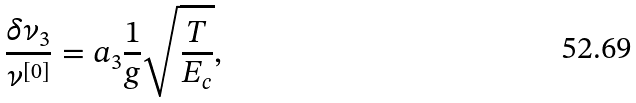Convert formula to latex. <formula><loc_0><loc_0><loc_500><loc_500>\frac { \delta \nu _ { 3 } } { \nu ^ { [ 0 ] } } = a _ { 3 } \frac { 1 } { g } \sqrt { \frac { T } { E _ { c } } } ,</formula> 